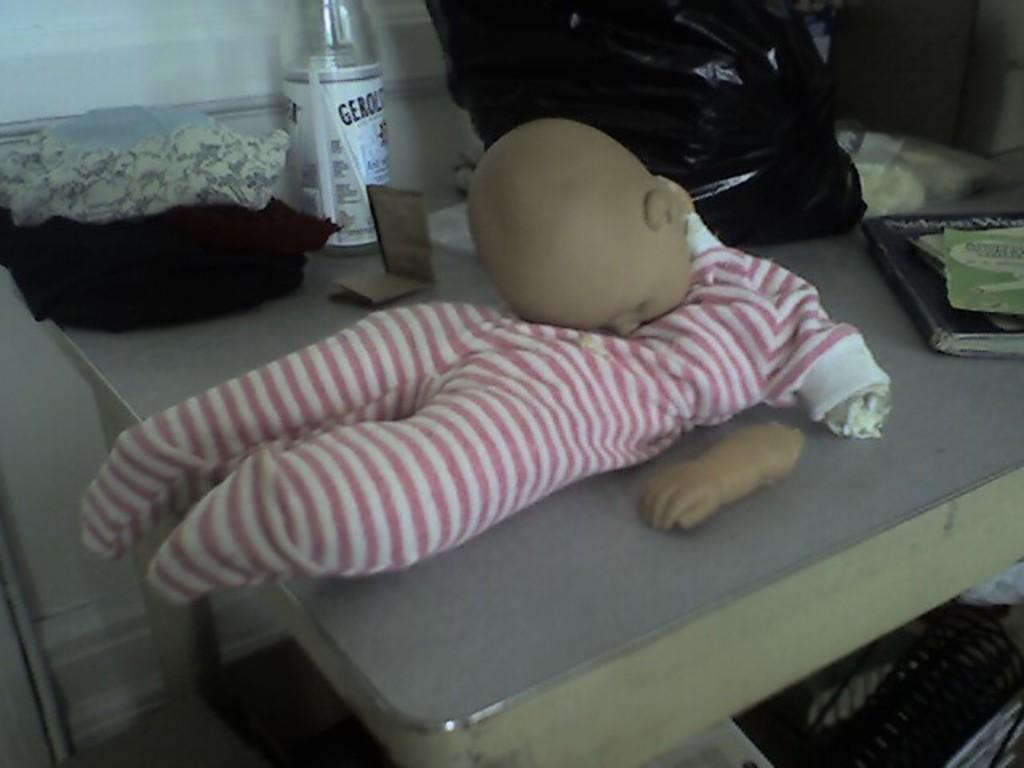What color is the table in the image? The table in the image is grey. What is placed on the table? A doll in a pink dress is placed on the table. What is the doll's hand doing in the image? The doll's hand is on the table. What color is the cloth in the image? The cloth in the image is black. What type of container is present in the image? A water bottle is present in the image. What is covering the table in the image? A black plastic cover is visible in the image. What else can be seen on the table besides the doll? There are books placed on the table. What type of quiver can be seen on the doll's back in the image? There is no quiver present on the doll's back in the image. What noise is the doll making in the image? The image does not depict any sound or noise being made by the doll. 